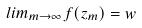Convert formula to latex. <formula><loc_0><loc_0><loc_500><loc_500>l i m _ { m \rightarrow \infty } f ( z _ { m } ) = w</formula> 